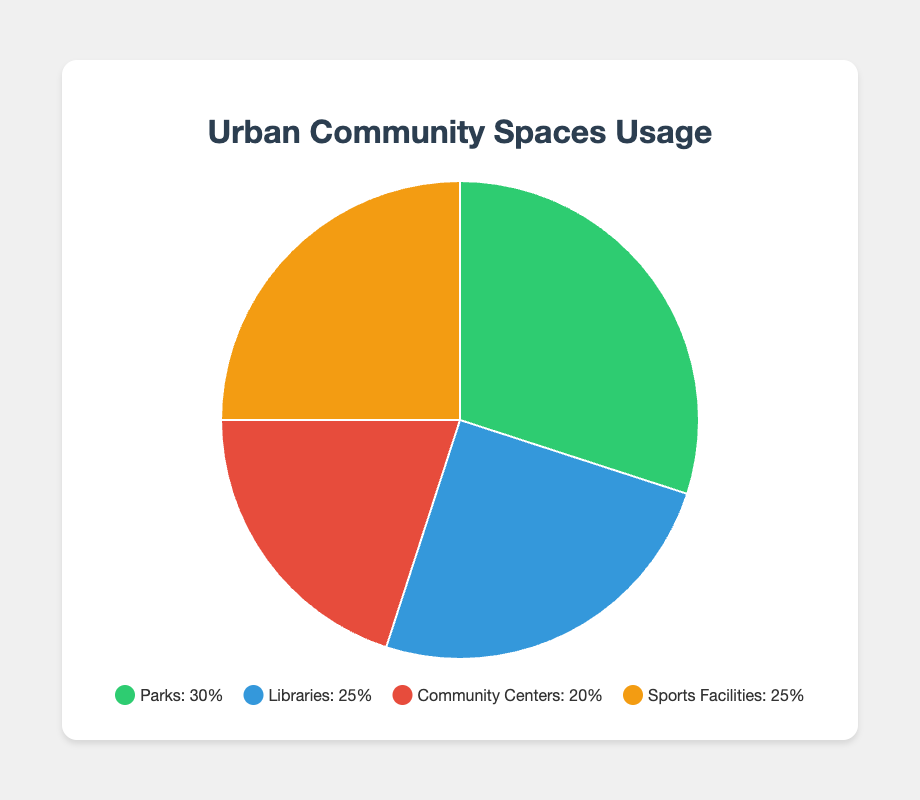What's the percentage usage of Parks compared to Libraries? Parks have 30% usage and Libraries have 25% usage. Thus, Parks have a higher usage than Libraries by 30% - 25% = 5%.
Answer: 5% Which community space has the lowest usage percentage? By looking at the pie chart, Community Centers have the lowest percentage at 20%, compared to Parks (30%), Libraries (25%), and Sports Facilities (25%).
Answer: Community Centers What is the total usage percentage of both Sports Facilities and Libraries combined? Sports Facilities have 25% usage and Libraries have 25% usage. Adding them together gives 25% + 25% = 50%.
Answer: 50% Among all data points, which two categories have equal usage percentages, and what are those percentages? The chart shows that Libraries and Sports Facilities both have usage percentages of 25%.
Answer: Libraries and Sports Facilities, 25% If we were to increase the usage of Community Centers by 10%, what would the new percentage be for Community Centers? Currently, Community Centers have 20% usage. Increasing this by 10% gives 20% + 10% = 30%.
Answer: 30% Which category represents a usage percentage that is the average of the usage percentages of Parks and Community Centers? The average of Parks (30%) and Community Centers (20%) is (30 + 20) / 2 = 25%. Both Libraries and Sports Facilities represent this average at 25%.
Answer: Libraries and Sports Facilities If the total usage of all community spaces is 100%, what is the combined percentage usage of Parks, Libraries, and Community Centers? Adding the percentages for Parks (30%), Libraries (25%), and Community Centers (20%), we get 30% + 25% + 20% = 75%.
Answer: 75% If we visualize the dominance in usage percentages by color representation, which colors correspond to the categories with the highest and lowest usage percentages? The highest percentage is Parks (30%) represented by green, and the lowest is Community Centers (20%) represented by red.
Answer: Green and Red 